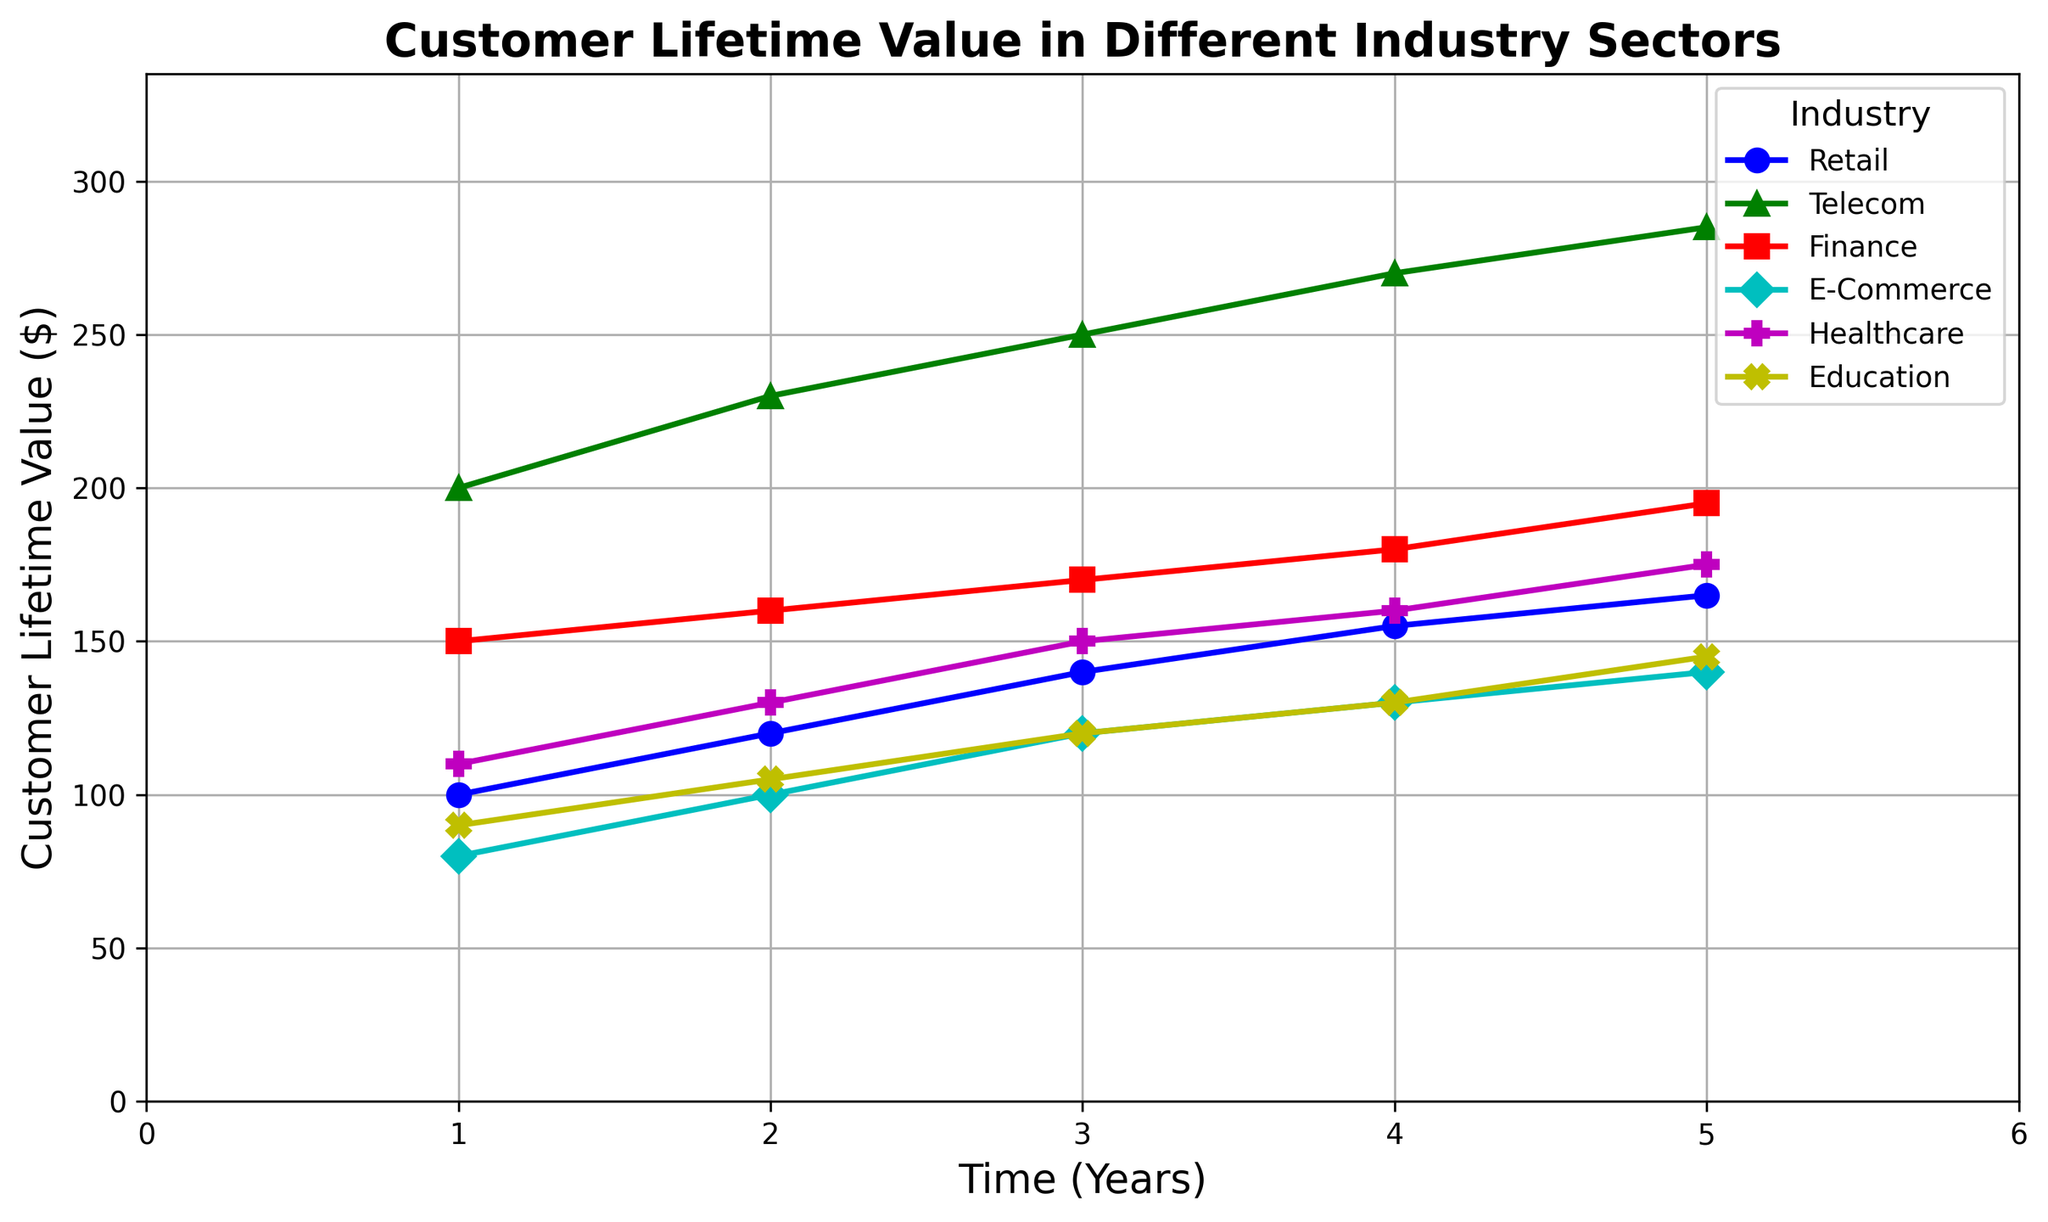Which industry has the highest Customer Lifetime Value (CLV) at Year 5? To determine this, look at the data points at Year 5 for each industry on the plot. The industry with the highest CLV at Year 5 can be identified. Telecom shows a CLV of 285 at Year 5, which is the highest among all industries.
Answer: Telecom Between Year 3 and Year 4, which industry showed the greatest increase in CLV? To find this, calculate the difference in CLV between Year 3 and Year 4 for each industry. Compare the increases across the industries. Telecom increased by 20 (270-250), which is the greatest increase between these years.
Answer: Telecom What is the average CLV of the Healthcare industry over the 5 years? Sum up the CLVs for Healthcare over the 5 years: \(110 + 130 + 150 + 160 + 175 = 725\). Then, divide by the number of years (5): \(725 / 5 = 145\).
Answer: 145 By how much did the CLV for the Retail industry increase from Year 1 to Year 5? Look at the CLV for Retail at Year 1 (100) and Year 5 (165). Subtract the Year 1 value from the Year 5 value: \(165 - 100 = 65\).
Answer: 65 Which industry has the slowest growth in CLV over the 5 years? Calculate the total increase in CLV from Year 1 to Year 5 for each industry and identify the smallest increase. E-Commerce has the slowest growth with an increase of \(140 - 80 = 60\).
Answer: E-Commerce Which two industries have the same CLV at Year 3? Examine the CLV values at Year 3 for all industries. Education and E-Commerce both have a CLV of 120 at Year 3.
Answer: Education and E-Commerce At which year did the Finance industry surpass the Retail industry in CLV? Compare the CLV values for Finance and Retail at each year. The Finance industry surpasses the Retail industry at Year 4, where Finance CLV is 180 and Retail CLV is 155.
Answer: Year 4 What is the total CLV for all industries combined at Year 2? Add up the CLV values for all industries at Year 2: \(120 + 230 + 160 + 100 + 130 + 105 = 845\).
Answer: 845 Which industry shows the steepest curve on the plot, indicating the fastest growth rate in CLV? Examine the visual steepness of the curves on the plot. The Telecom industry shows the steepest curve, indicating the fastest growth rate in CLV.
Answer: Telecom How does the CLV of the Education industry in Year 5 compare to the CLV of the Healthcare industry in Year 3? Look at the CLV values: Education industry in Year 5 is 145 and Healthcare industry in Year 3 is 150. The Education industry's CLV in Year 5 is slightly less than the Healthcare industry's CLV in Year 3.
Answer: Less 